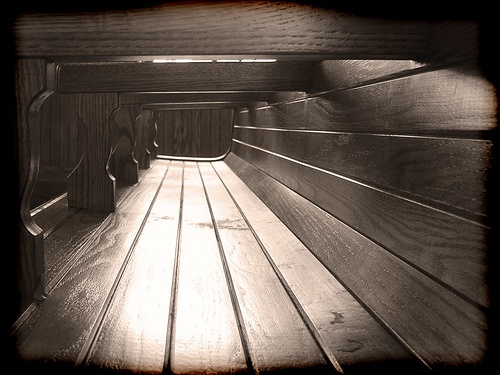Describe the objects in this image and their specific colors. I can see a bench in black, gray, and white tones in this image. 